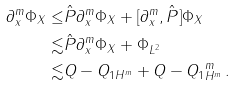Convert formula to latex. <formula><loc_0><loc_0><loc_500><loc_500>\| \partial _ { x } ^ { m } \Phi \| _ { X } \leq & \| \hat { P } \partial _ { x } ^ { m } \Phi \| _ { X } + \| [ \partial _ { x } ^ { m } , \hat { P } ] \Phi \| _ { X } \\ \lesssim & \| \hat { P } \partial _ { x } ^ { m } \Phi \| _ { X } + \| \Phi \| _ { L ^ { 2 } } \\ \lesssim & \| Q - Q _ { 1 } \| _ { H ^ { m } } + \| Q - Q _ { 1 } \| _ { H ^ { m } } ^ { m } \, .</formula> 